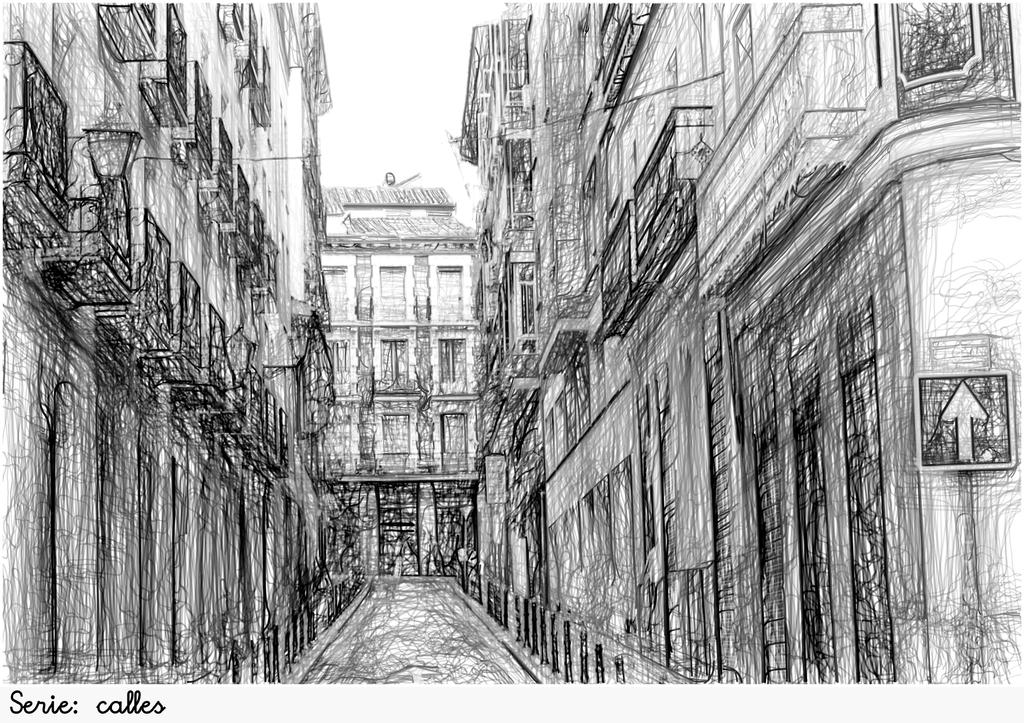What type of drawing is depicted in the image? The image contains a pencil sketch of buildings. What else can be seen in the image besides the buildings? There is a road, a sign board, a street light, and wires visible in the image. What is the purpose of the sign board in the image? The purpose of the sign board is to provide information or directions to people in the area. What is the source of light for the street at night in the image? The street light provides light for the street at night in the image. What force is responsible for the earth's attraction in the image? There is no reference to the earth's attraction or any force in the image; it contains a pencil sketch of buildings and related elements. 